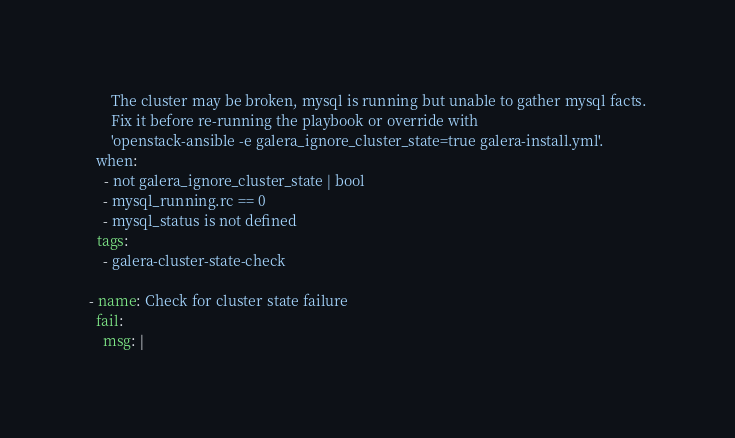<code> <loc_0><loc_0><loc_500><loc_500><_YAML_>      The cluster may be broken, mysql is running but unable to gather mysql facts.
      Fix it before re-running the playbook or override with
      'openstack-ansible -e galera_ignore_cluster_state=true galera-install.yml'.
  when:
    - not galera_ignore_cluster_state | bool
    - mysql_running.rc == 0
    - mysql_status is not defined
  tags:
    - galera-cluster-state-check

- name: Check for cluster state failure
  fail:
    msg: |</code> 